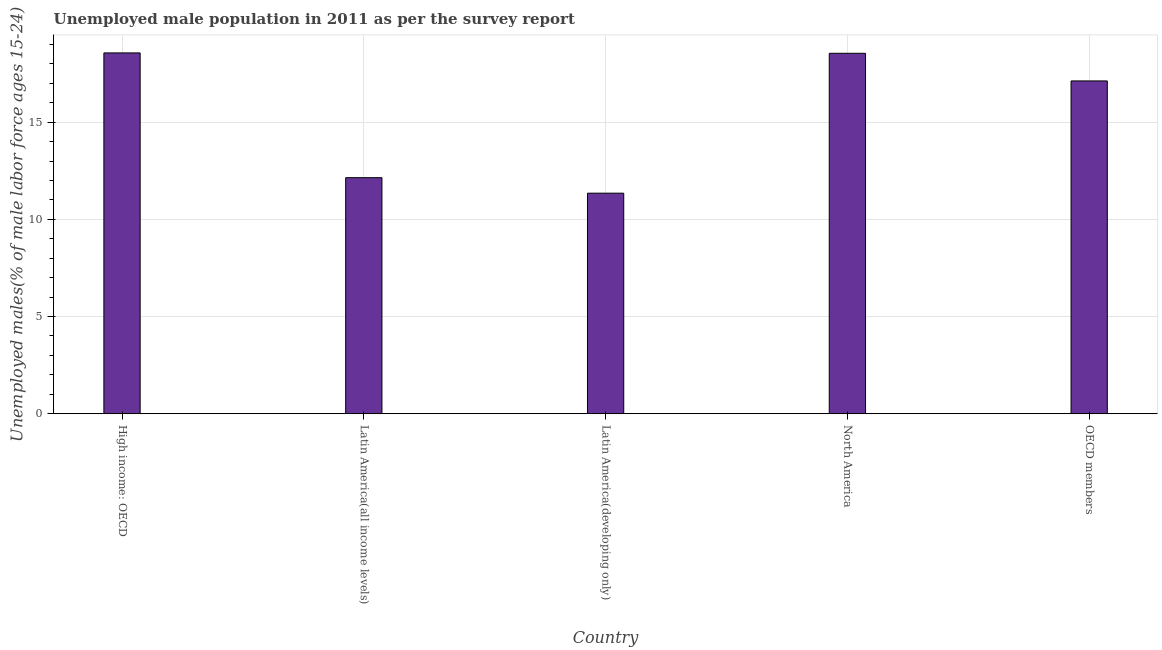Does the graph contain grids?
Offer a very short reply. Yes. What is the title of the graph?
Ensure brevity in your answer.  Unemployed male population in 2011 as per the survey report. What is the label or title of the Y-axis?
Offer a terse response. Unemployed males(% of male labor force ages 15-24). What is the unemployed male youth in OECD members?
Keep it short and to the point. 17.12. Across all countries, what is the maximum unemployed male youth?
Ensure brevity in your answer.  18.56. Across all countries, what is the minimum unemployed male youth?
Provide a short and direct response. 11.35. In which country was the unemployed male youth maximum?
Ensure brevity in your answer.  High income: OECD. In which country was the unemployed male youth minimum?
Keep it short and to the point. Latin America(developing only). What is the sum of the unemployed male youth?
Offer a terse response. 77.73. What is the difference between the unemployed male youth in High income: OECD and Latin America(all income levels)?
Ensure brevity in your answer.  6.42. What is the average unemployed male youth per country?
Your answer should be compact. 15.55. What is the median unemployed male youth?
Offer a terse response. 17.12. In how many countries, is the unemployed male youth greater than 4 %?
Ensure brevity in your answer.  5. What is the ratio of the unemployed male youth in Latin America(developing only) to that in North America?
Provide a succinct answer. 0.61. Is the unemployed male youth in High income: OECD less than that in North America?
Provide a succinct answer. No. Is the difference between the unemployed male youth in High income: OECD and Latin America(all income levels) greater than the difference between any two countries?
Your response must be concise. No. What is the difference between the highest and the second highest unemployed male youth?
Ensure brevity in your answer.  0.02. Is the sum of the unemployed male youth in High income: OECD and OECD members greater than the maximum unemployed male youth across all countries?
Your answer should be very brief. Yes. What is the difference between the highest and the lowest unemployed male youth?
Keep it short and to the point. 7.22. What is the difference between two consecutive major ticks on the Y-axis?
Make the answer very short. 5. What is the Unemployed males(% of male labor force ages 15-24) of High income: OECD?
Provide a short and direct response. 18.56. What is the Unemployed males(% of male labor force ages 15-24) of Latin America(all income levels)?
Your answer should be very brief. 12.15. What is the Unemployed males(% of male labor force ages 15-24) in Latin America(developing only)?
Offer a very short reply. 11.35. What is the Unemployed males(% of male labor force ages 15-24) in North America?
Offer a terse response. 18.55. What is the Unemployed males(% of male labor force ages 15-24) of OECD members?
Provide a short and direct response. 17.12. What is the difference between the Unemployed males(% of male labor force ages 15-24) in High income: OECD and Latin America(all income levels)?
Your answer should be very brief. 6.42. What is the difference between the Unemployed males(% of male labor force ages 15-24) in High income: OECD and Latin America(developing only)?
Keep it short and to the point. 7.22. What is the difference between the Unemployed males(% of male labor force ages 15-24) in High income: OECD and North America?
Offer a terse response. 0.02. What is the difference between the Unemployed males(% of male labor force ages 15-24) in High income: OECD and OECD members?
Provide a short and direct response. 1.44. What is the difference between the Unemployed males(% of male labor force ages 15-24) in Latin America(all income levels) and Latin America(developing only)?
Give a very brief answer. 0.8. What is the difference between the Unemployed males(% of male labor force ages 15-24) in Latin America(all income levels) and North America?
Make the answer very short. -6.4. What is the difference between the Unemployed males(% of male labor force ages 15-24) in Latin America(all income levels) and OECD members?
Your answer should be compact. -4.98. What is the difference between the Unemployed males(% of male labor force ages 15-24) in Latin America(developing only) and North America?
Your answer should be compact. -7.2. What is the difference between the Unemployed males(% of male labor force ages 15-24) in Latin America(developing only) and OECD members?
Offer a terse response. -5.78. What is the difference between the Unemployed males(% of male labor force ages 15-24) in North America and OECD members?
Offer a very short reply. 1.42. What is the ratio of the Unemployed males(% of male labor force ages 15-24) in High income: OECD to that in Latin America(all income levels)?
Your answer should be compact. 1.53. What is the ratio of the Unemployed males(% of male labor force ages 15-24) in High income: OECD to that in Latin America(developing only)?
Your answer should be very brief. 1.64. What is the ratio of the Unemployed males(% of male labor force ages 15-24) in High income: OECD to that in North America?
Your response must be concise. 1. What is the ratio of the Unemployed males(% of male labor force ages 15-24) in High income: OECD to that in OECD members?
Make the answer very short. 1.08. What is the ratio of the Unemployed males(% of male labor force ages 15-24) in Latin America(all income levels) to that in Latin America(developing only)?
Your response must be concise. 1.07. What is the ratio of the Unemployed males(% of male labor force ages 15-24) in Latin America(all income levels) to that in North America?
Keep it short and to the point. 0.66. What is the ratio of the Unemployed males(% of male labor force ages 15-24) in Latin America(all income levels) to that in OECD members?
Ensure brevity in your answer.  0.71. What is the ratio of the Unemployed males(% of male labor force ages 15-24) in Latin America(developing only) to that in North America?
Offer a very short reply. 0.61. What is the ratio of the Unemployed males(% of male labor force ages 15-24) in Latin America(developing only) to that in OECD members?
Offer a terse response. 0.66. What is the ratio of the Unemployed males(% of male labor force ages 15-24) in North America to that in OECD members?
Ensure brevity in your answer.  1.08. 